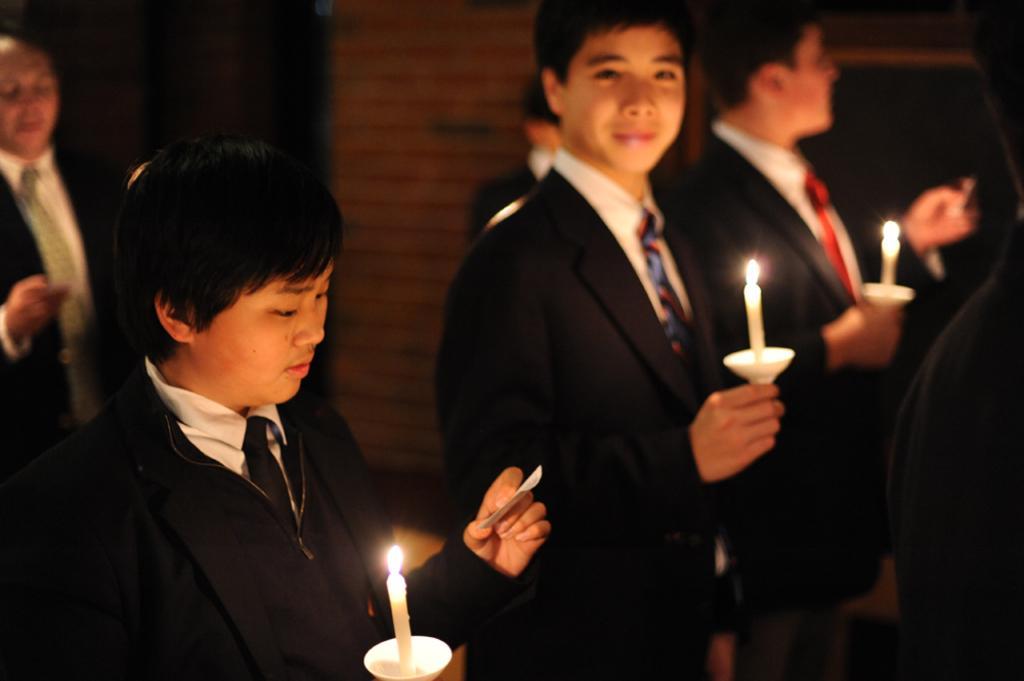Please provide a concise description of this image. This picture describes about group of people, few people holding candles and papers. 